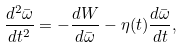Convert formula to latex. <formula><loc_0><loc_0><loc_500><loc_500>\frac { d ^ { 2 } \bar { \omega } } { d t ^ { 2 } } = - \frac { d W } { d \bar { \omega } } - \eta ( t ) \frac { d \bar { \omega } } { d t } ,</formula> 